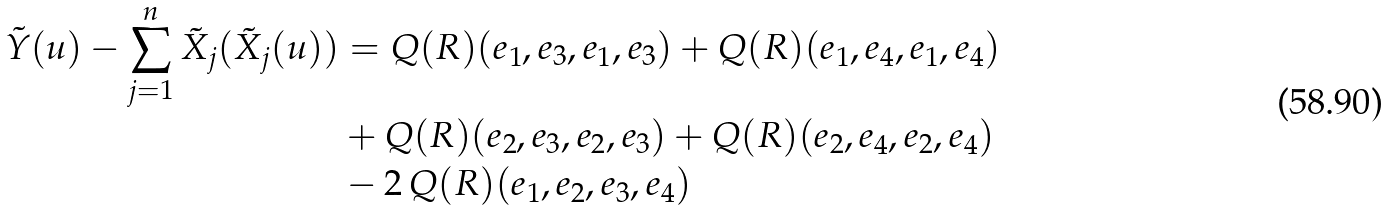<formula> <loc_0><loc_0><loc_500><loc_500>\tilde { Y } ( u ) - \sum _ { j = 1 } ^ { n } \tilde { X } _ { j } ( \tilde { X } _ { j } ( u ) ) & = Q ( R ) ( e _ { 1 } , e _ { 3 } , e _ { 1 } , e _ { 3 } ) + Q ( R ) ( e _ { 1 } , e _ { 4 } , e _ { 1 } , e _ { 4 } ) \\ & + Q ( R ) ( e _ { 2 } , e _ { 3 } , e _ { 2 } , e _ { 3 } ) + Q ( R ) ( e _ { 2 } , e _ { 4 } , e _ { 2 } , e _ { 4 } ) \\ & - 2 \, Q ( R ) ( e _ { 1 } , e _ { 2 } , e _ { 3 } , e _ { 4 } )</formula> 